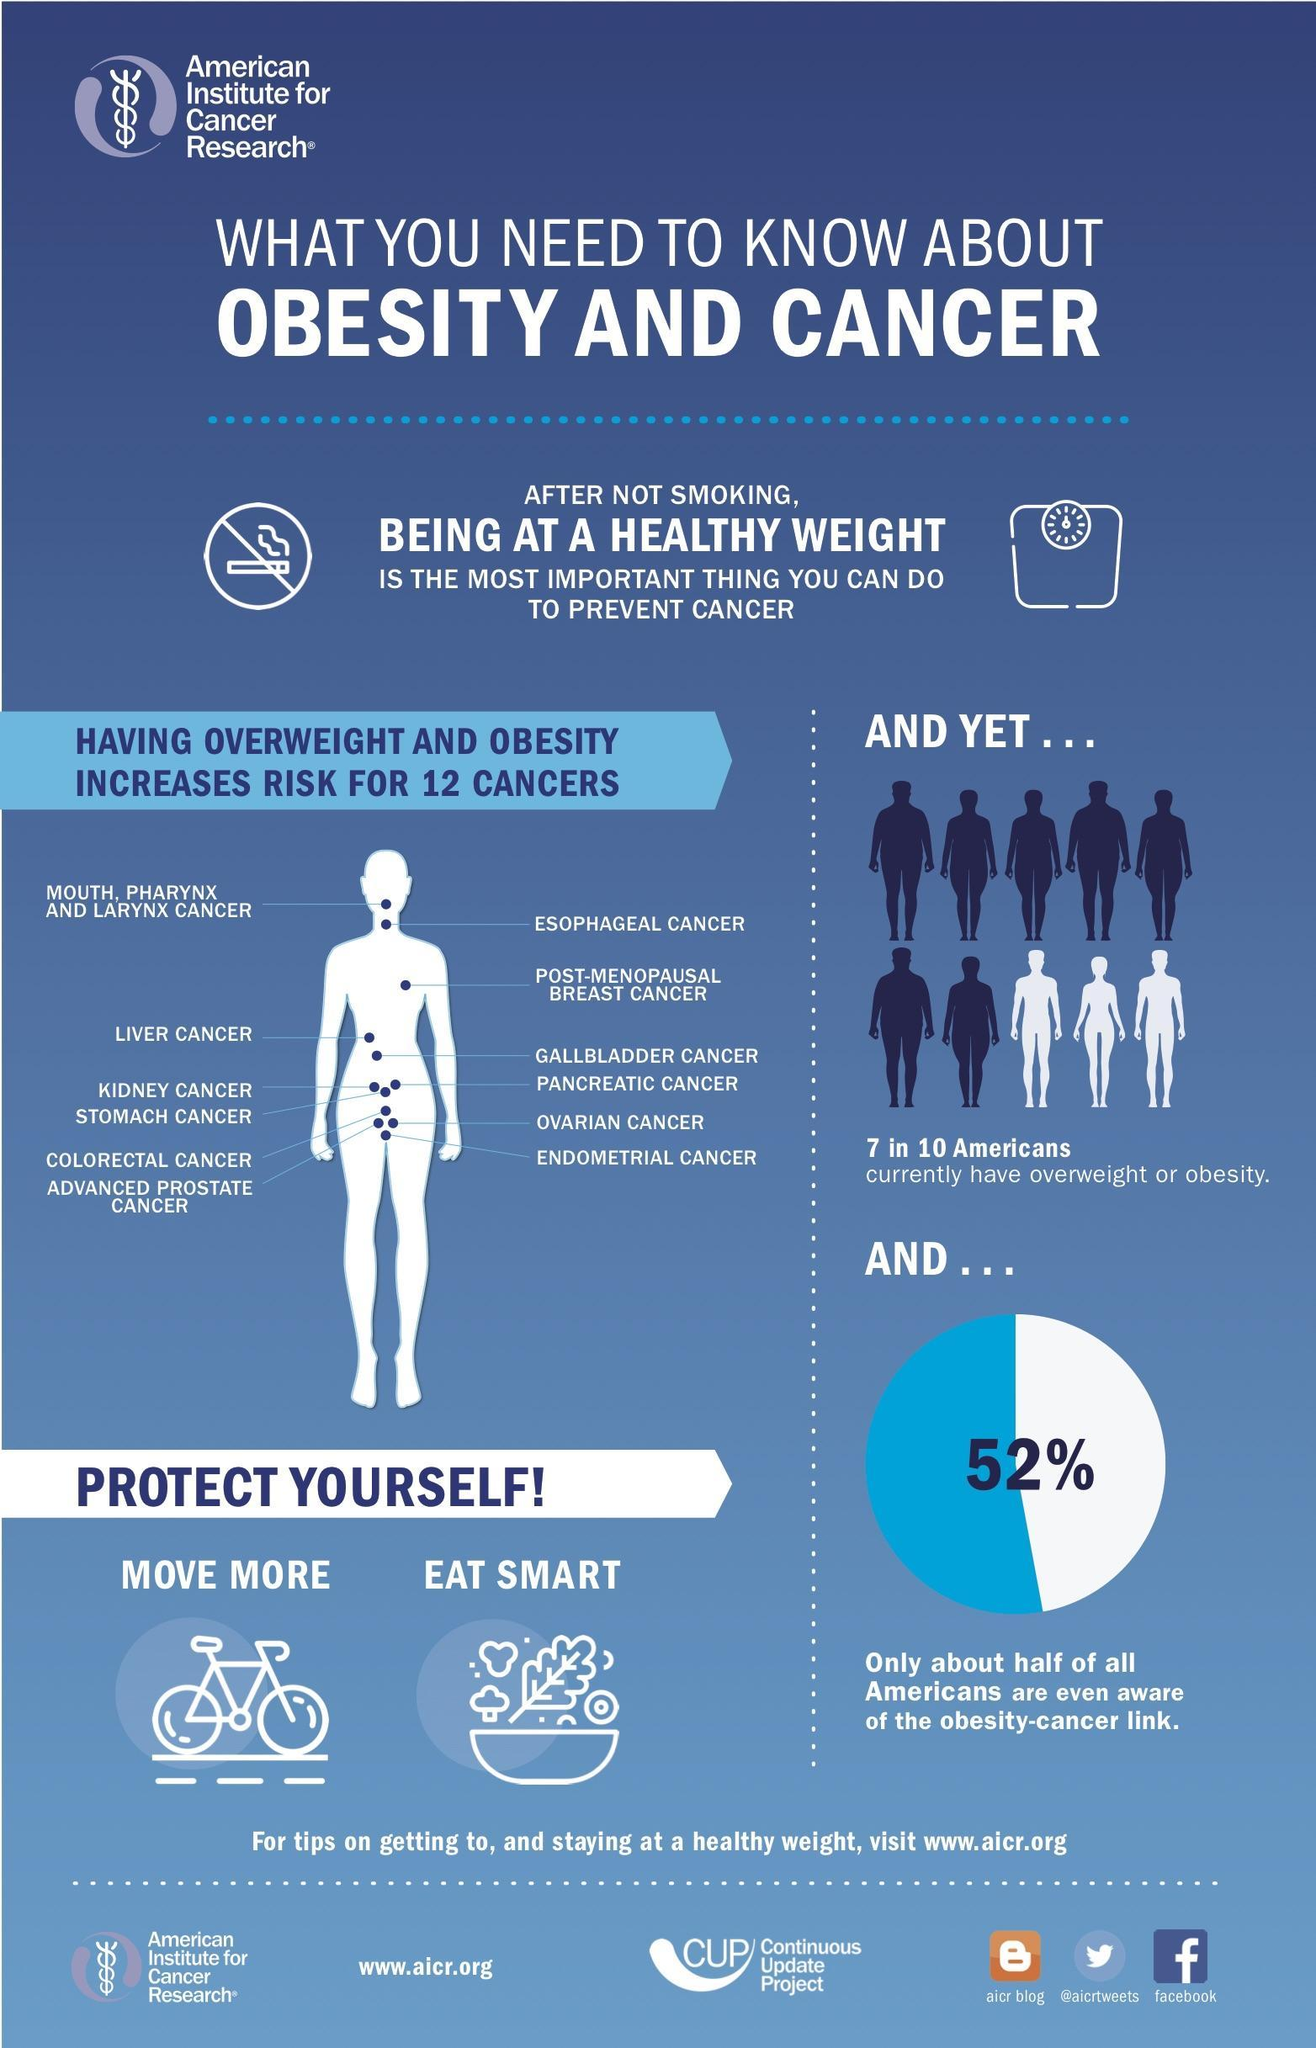What is the second most important thing to prevent cancer?
Answer the question with a short phrase. Healthy weight Out of 10 Americans, how many are not overweighted? 3 What is the most important thing to prevent cancer? Not smoking What percentage of Americans are unaware of the obesity-cancer link? 48% 